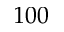<formula> <loc_0><loc_0><loc_500><loc_500>1 0 0</formula> 